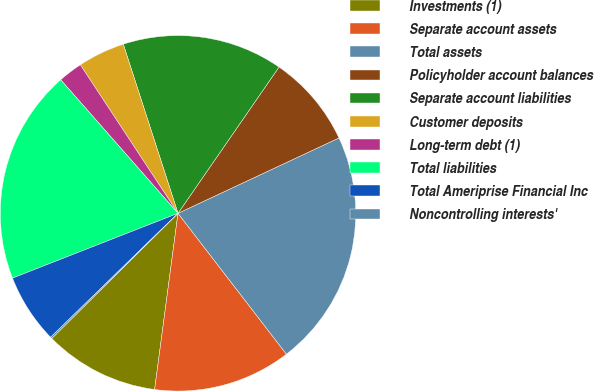Convert chart to OTSL. <chart><loc_0><loc_0><loc_500><loc_500><pie_chart><fcel>Investments (1)<fcel>Separate account assets<fcel>Total assets<fcel>Policyholder account balances<fcel>Separate account liabilities<fcel>Customer deposits<fcel>Long-term debt (1)<fcel>Total liabilities<fcel>Total Ameriprise Financial Inc<fcel>Noncontrolling interests'<nl><fcel>10.47%<fcel>12.54%<fcel>21.53%<fcel>8.41%<fcel>14.6%<fcel>4.28%<fcel>2.21%<fcel>19.47%<fcel>6.34%<fcel>0.15%<nl></chart> 